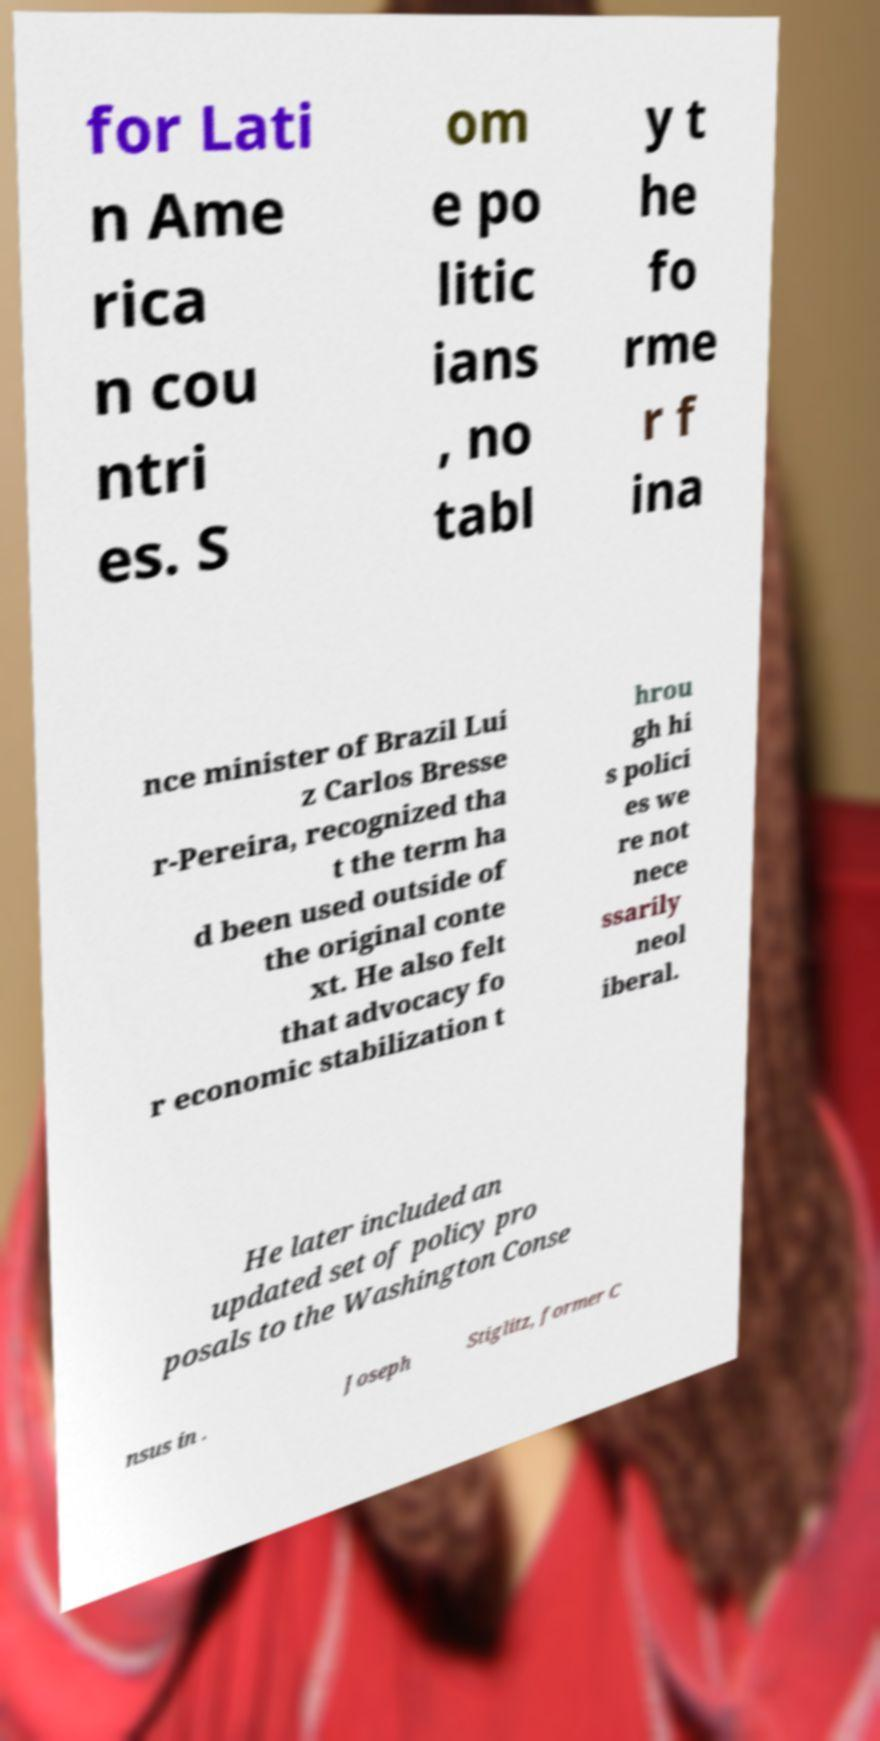For documentation purposes, I need the text within this image transcribed. Could you provide that? for Lati n Ame rica n cou ntri es. S om e po litic ians , no tabl y t he fo rme r f ina nce minister of Brazil Lui z Carlos Bresse r-Pereira, recognized tha t the term ha d been used outside of the original conte xt. He also felt that advocacy fo r economic stabilization t hrou gh hi s polici es we re not nece ssarily neol iberal. He later included an updated set of policy pro posals to the Washington Conse nsus in . Joseph Stiglitz, former C 